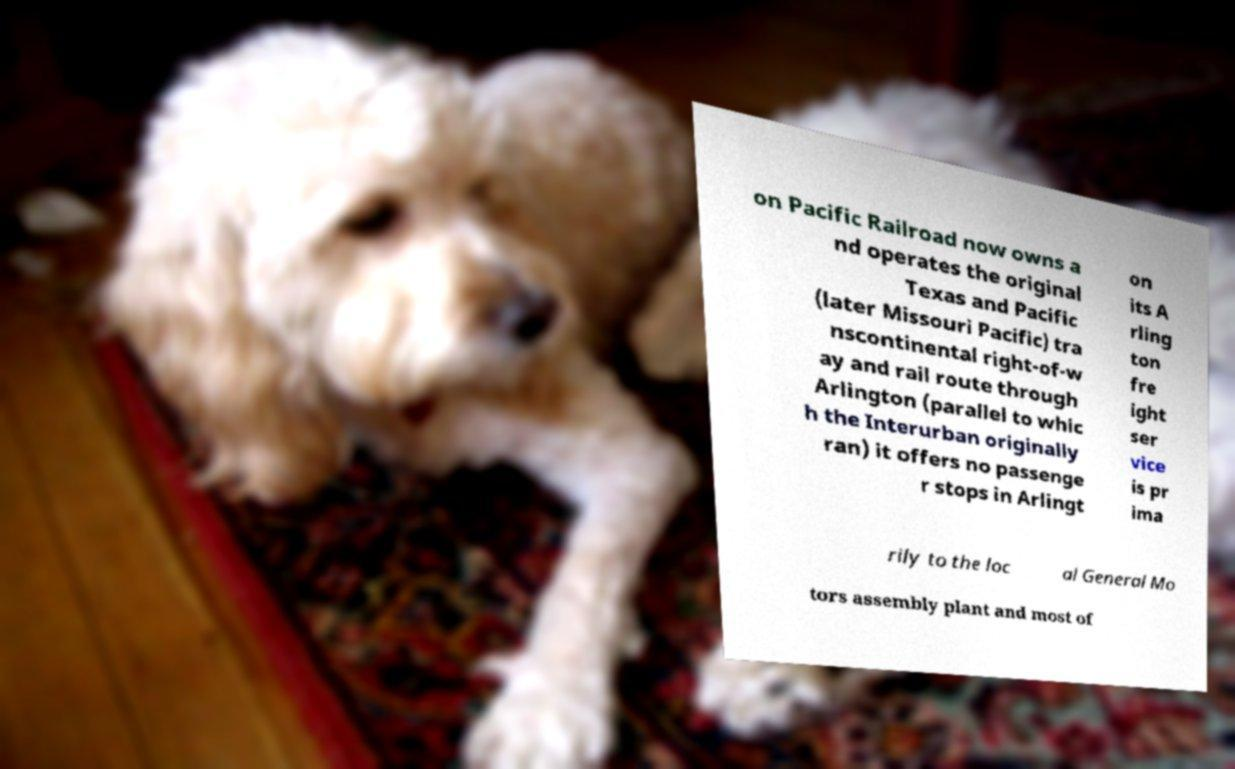There's text embedded in this image that I need extracted. Can you transcribe it verbatim? on Pacific Railroad now owns a nd operates the original Texas and Pacific (later Missouri Pacific) tra nscontinental right-of-w ay and rail route through Arlington (parallel to whic h the Interurban originally ran) it offers no passenge r stops in Arlingt on its A rling ton fre ight ser vice is pr ima rily to the loc al General Mo tors assembly plant and most of 